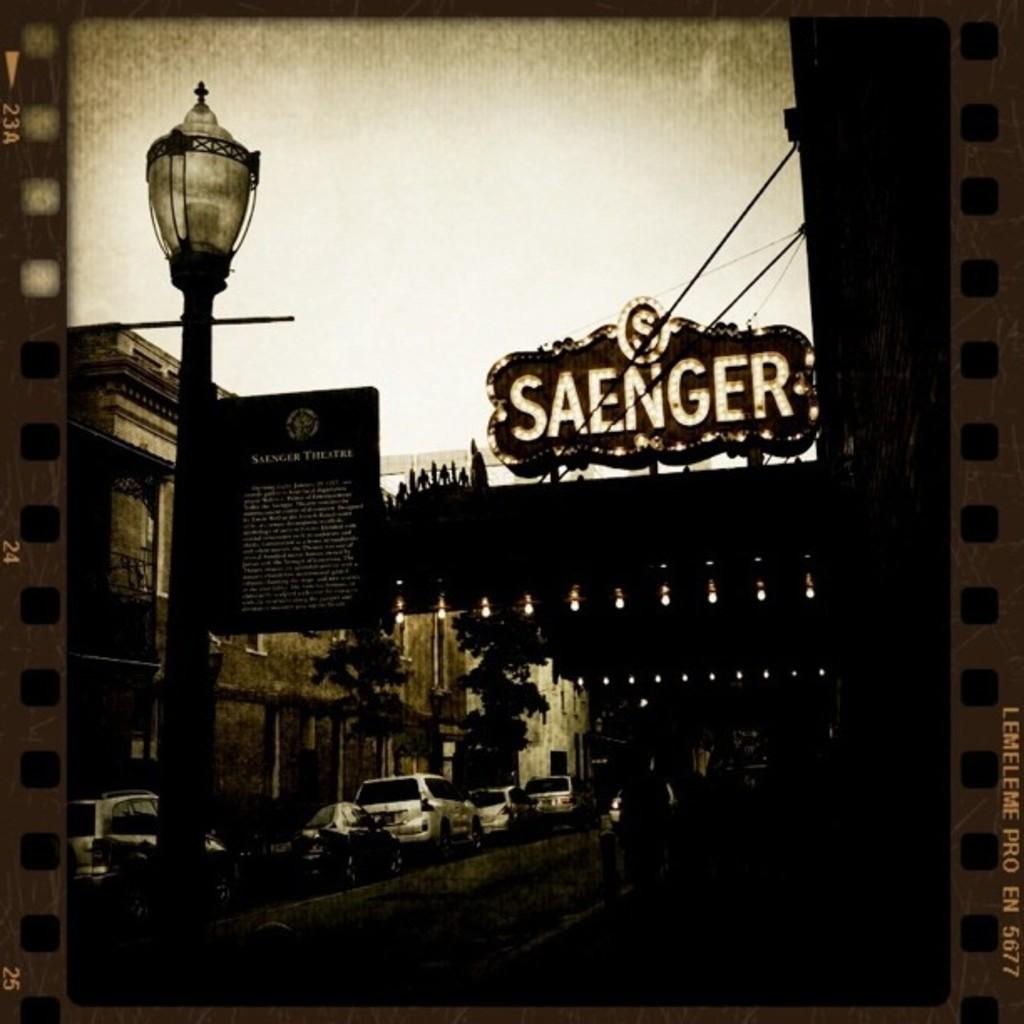What types of objects can be seen in the image? There are vehicles, buildings, trees, and a pole in the image. What else is present in the image? There are lights and text on the right side of the image. What flavor of tin can be seen in the image? There is no tin present in the image, and therefore no flavor can be associated with it. Can you describe the airplane in the image? There is no airplane present in the image. 